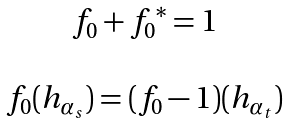<formula> <loc_0><loc_0><loc_500><loc_500>\begin{matrix} f _ { 0 } + { f _ { 0 } } ^ { * } = 1 \\ \\ f _ { 0 } ( h _ { \alpha _ { s } } ) = ( f _ { 0 } - 1 ) ( h _ { \alpha _ { t } } ) \end{matrix}</formula> 